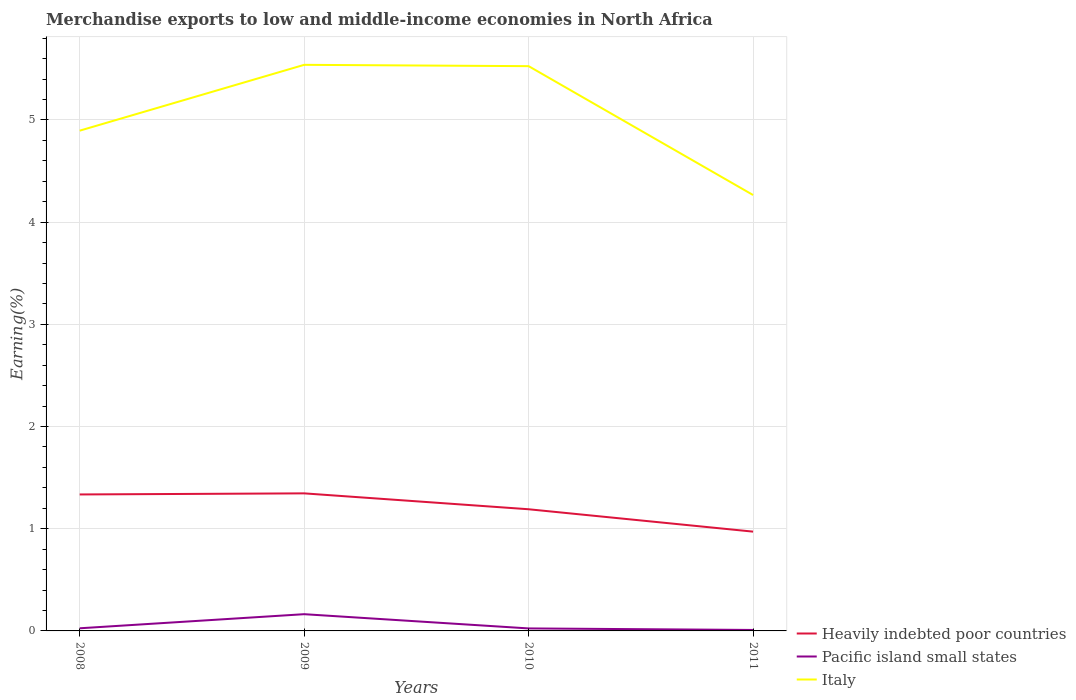How many different coloured lines are there?
Provide a short and direct response. 3. Is the number of lines equal to the number of legend labels?
Give a very brief answer. Yes. Across all years, what is the maximum percentage of amount earned from merchandise exports in Italy?
Offer a very short reply. 4.27. In which year was the percentage of amount earned from merchandise exports in Heavily indebted poor countries maximum?
Ensure brevity in your answer.  2011. What is the total percentage of amount earned from merchandise exports in Italy in the graph?
Ensure brevity in your answer.  1.26. What is the difference between the highest and the second highest percentage of amount earned from merchandise exports in Italy?
Your response must be concise. 1.27. How many years are there in the graph?
Keep it short and to the point. 4. What is the difference between two consecutive major ticks on the Y-axis?
Your answer should be very brief. 1. Does the graph contain any zero values?
Your response must be concise. No. Does the graph contain grids?
Your answer should be very brief. Yes. Where does the legend appear in the graph?
Offer a terse response. Bottom right. What is the title of the graph?
Ensure brevity in your answer.  Merchandise exports to low and middle-income economies in North Africa. Does "Saudi Arabia" appear as one of the legend labels in the graph?
Your answer should be compact. No. What is the label or title of the Y-axis?
Provide a short and direct response. Earning(%). What is the Earning(%) in Heavily indebted poor countries in 2008?
Give a very brief answer. 1.34. What is the Earning(%) of Pacific island small states in 2008?
Your answer should be very brief. 0.03. What is the Earning(%) of Italy in 2008?
Your answer should be compact. 4.89. What is the Earning(%) in Heavily indebted poor countries in 2009?
Give a very brief answer. 1.35. What is the Earning(%) of Pacific island small states in 2009?
Offer a very short reply. 0.16. What is the Earning(%) in Italy in 2009?
Ensure brevity in your answer.  5.54. What is the Earning(%) in Heavily indebted poor countries in 2010?
Offer a terse response. 1.19. What is the Earning(%) in Pacific island small states in 2010?
Your response must be concise. 0.02. What is the Earning(%) of Italy in 2010?
Make the answer very short. 5.53. What is the Earning(%) of Heavily indebted poor countries in 2011?
Offer a very short reply. 0.97. What is the Earning(%) in Pacific island small states in 2011?
Provide a succinct answer. 0.01. What is the Earning(%) in Italy in 2011?
Your answer should be very brief. 4.27. Across all years, what is the maximum Earning(%) of Heavily indebted poor countries?
Offer a very short reply. 1.35. Across all years, what is the maximum Earning(%) in Pacific island small states?
Make the answer very short. 0.16. Across all years, what is the maximum Earning(%) in Italy?
Give a very brief answer. 5.54. Across all years, what is the minimum Earning(%) of Heavily indebted poor countries?
Provide a succinct answer. 0.97. Across all years, what is the minimum Earning(%) of Pacific island small states?
Make the answer very short. 0.01. Across all years, what is the minimum Earning(%) of Italy?
Ensure brevity in your answer.  4.27. What is the total Earning(%) in Heavily indebted poor countries in the graph?
Your response must be concise. 4.84. What is the total Earning(%) in Pacific island small states in the graph?
Your response must be concise. 0.22. What is the total Earning(%) in Italy in the graph?
Your answer should be very brief. 20.23. What is the difference between the Earning(%) in Heavily indebted poor countries in 2008 and that in 2009?
Your response must be concise. -0.01. What is the difference between the Earning(%) in Pacific island small states in 2008 and that in 2009?
Provide a short and direct response. -0.14. What is the difference between the Earning(%) of Italy in 2008 and that in 2009?
Make the answer very short. -0.64. What is the difference between the Earning(%) in Heavily indebted poor countries in 2008 and that in 2010?
Make the answer very short. 0.14. What is the difference between the Earning(%) of Pacific island small states in 2008 and that in 2010?
Ensure brevity in your answer.  0. What is the difference between the Earning(%) of Italy in 2008 and that in 2010?
Your answer should be compact. -0.63. What is the difference between the Earning(%) of Heavily indebted poor countries in 2008 and that in 2011?
Keep it short and to the point. 0.36. What is the difference between the Earning(%) in Pacific island small states in 2008 and that in 2011?
Your answer should be compact. 0.02. What is the difference between the Earning(%) in Italy in 2008 and that in 2011?
Your answer should be very brief. 0.63. What is the difference between the Earning(%) of Heavily indebted poor countries in 2009 and that in 2010?
Your answer should be compact. 0.16. What is the difference between the Earning(%) of Pacific island small states in 2009 and that in 2010?
Your response must be concise. 0.14. What is the difference between the Earning(%) of Italy in 2009 and that in 2010?
Provide a succinct answer. 0.01. What is the difference between the Earning(%) in Heavily indebted poor countries in 2009 and that in 2011?
Give a very brief answer. 0.37. What is the difference between the Earning(%) of Pacific island small states in 2009 and that in 2011?
Give a very brief answer. 0.15. What is the difference between the Earning(%) in Italy in 2009 and that in 2011?
Provide a short and direct response. 1.27. What is the difference between the Earning(%) of Heavily indebted poor countries in 2010 and that in 2011?
Keep it short and to the point. 0.22. What is the difference between the Earning(%) in Pacific island small states in 2010 and that in 2011?
Give a very brief answer. 0.02. What is the difference between the Earning(%) of Italy in 2010 and that in 2011?
Ensure brevity in your answer.  1.26. What is the difference between the Earning(%) in Heavily indebted poor countries in 2008 and the Earning(%) in Pacific island small states in 2009?
Offer a very short reply. 1.17. What is the difference between the Earning(%) in Heavily indebted poor countries in 2008 and the Earning(%) in Italy in 2009?
Ensure brevity in your answer.  -4.2. What is the difference between the Earning(%) of Pacific island small states in 2008 and the Earning(%) of Italy in 2009?
Your answer should be compact. -5.51. What is the difference between the Earning(%) of Heavily indebted poor countries in 2008 and the Earning(%) of Pacific island small states in 2010?
Provide a short and direct response. 1.31. What is the difference between the Earning(%) of Heavily indebted poor countries in 2008 and the Earning(%) of Italy in 2010?
Give a very brief answer. -4.19. What is the difference between the Earning(%) of Pacific island small states in 2008 and the Earning(%) of Italy in 2010?
Make the answer very short. -5.5. What is the difference between the Earning(%) of Heavily indebted poor countries in 2008 and the Earning(%) of Pacific island small states in 2011?
Offer a terse response. 1.33. What is the difference between the Earning(%) in Heavily indebted poor countries in 2008 and the Earning(%) in Italy in 2011?
Offer a terse response. -2.93. What is the difference between the Earning(%) in Pacific island small states in 2008 and the Earning(%) in Italy in 2011?
Offer a very short reply. -4.24. What is the difference between the Earning(%) of Heavily indebted poor countries in 2009 and the Earning(%) of Pacific island small states in 2010?
Provide a succinct answer. 1.32. What is the difference between the Earning(%) of Heavily indebted poor countries in 2009 and the Earning(%) of Italy in 2010?
Your answer should be very brief. -4.18. What is the difference between the Earning(%) in Pacific island small states in 2009 and the Earning(%) in Italy in 2010?
Offer a very short reply. -5.36. What is the difference between the Earning(%) of Heavily indebted poor countries in 2009 and the Earning(%) of Pacific island small states in 2011?
Your response must be concise. 1.34. What is the difference between the Earning(%) in Heavily indebted poor countries in 2009 and the Earning(%) in Italy in 2011?
Your answer should be very brief. -2.92. What is the difference between the Earning(%) of Pacific island small states in 2009 and the Earning(%) of Italy in 2011?
Keep it short and to the point. -4.1. What is the difference between the Earning(%) of Heavily indebted poor countries in 2010 and the Earning(%) of Pacific island small states in 2011?
Your response must be concise. 1.18. What is the difference between the Earning(%) in Heavily indebted poor countries in 2010 and the Earning(%) in Italy in 2011?
Your answer should be very brief. -3.07. What is the difference between the Earning(%) of Pacific island small states in 2010 and the Earning(%) of Italy in 2011?
Ensure brevity in your answer.  -4.24. What is the average Earning(%) of Heavily indebted poor countries per year?
Your answer should be compact. 1.21. What is the average Earning(%) in Pacific island small states per year?
Your answer should be very brief. 0.06. What is the average Earning(%) in Italy per year?
Your answer should be very brief. 5.06. In the year 2008, what is the difference between the Earning(%) in Heavily indebted poor countries and Earning(%) in Pacific island small states?
Offer a very short reply. 1.31. In the year 2008, what is the difference between the Earning(%) of Heavily indebted poor countries and Earning(%) of Italy?
Provide a succinct answer. -3.56. In the year 2008, what is the difference between the Earning(%) in Pacific island small states and Earning(%) in Italy?
Your response must be concise. -4.87. In the year 2009, what is the difference between the Earning(%) in Heavily indebted poor countries and Earning(%) in Pacific island small states?
Ensure brevity in your answer.  1.18. In the year 2009, what is the difference between the Earning(%) of Heavily indebted poor countries and Earning(%) of Italy?
Offer a terse response. -4.19. In the year 2009, what is the difference between the Earning(%) of Pacific island small states and Earning(%) of Italy?
Provide a short and direct response. -5.38. In the year 2010, what is the difference between the Earning(%) of Heavily indebted poor countries and Earning(%) of Pacific island small states?
Give a very brief answer. 1.17. In the year 2010, what is the difference between the Earning(%) of Heavily indebted poor countries and Earning(%) of Italy?
Offer a very short reply. -4.34. In the year 2010, what is the difference between the Earning(%) of Pacific island small states and Earning(%) of Italy?
Provide a short and direct response. -5.5. In the year 2011, what is the difference between the Earning(%) in Heavily indebted poor countries and Earning(%) in Pacific island small states?
Keep it short and to the point. 0.96. In the year 2011, what is the difference between the Earning(%) in Heavily indebted poor countries and Earning(%) in Italy?
Make the answer very short. -3.29. In the year 2011, what is the difference between the Earning(%) in Pacific island small states and Earning(%) in Italy?
Offer a very short reply. -4.26. What is the ratio of the Earning(%) in Heavily indebted poor countries in 2008 to that in 2009?
Your answer should be very brief. 0.99. What is the ratio of the Earning(%) of Pacific island small states in 2008 to that in 2009?
Your answer should be compact. 0.16. What is the ratio of the Earning(%) in Italy in 2008 to that in 2009?
Keep it short and to the point. 0.88. What is the ratio of the Earning(%) of Heavily indebted poor countries in 2008 to that in 2010?
Offer a terse response. 1.12. What is the ratio of the Earning(%) of Pacific island small states in 2008 to that in 2010?
Keep it short and to the point. 1.05. What is the ratio of the Earning(%) of Italy in 2008 to that in 2010?
Your answer should be very brief. 0.89. What is the ratio of the Earning(%) in Heavily indebted poor countries in 2008 to that in 2011?
Your response must be concise. 1.37. What is the ratio of the Earning(%) in Pacific island small states in 2008 to that in 2011?
Make the answer very short. 2.74. What is the ratio of the Earning(%) in Italy in 2008 to that in 2011?
Your answer should be very brief. 1.15. What is the ratio of the Earning(%) in Heavily indebted poor countries in 2009 to that in 2010?
Your answer should be compact. 1.13. What is the ratio of the Earning(%) in Pacific island small states in 2009 to that in 2010?
Ensure brevity in your answer.  6.68. What is the ratio of the Earning(%) of Heavily indebted poor countries in 2009 to that in 2011?
Provide a succinct answer. 1.39. What is the ratio of the Earning(%) in Pacific island small states in 2009 to that in 2011?
Keep it short and to the point. 17.37. What is the ratio of the Earning(%) of Italy in 2009 to that in 2011?
Your answer should be very brief. 1.3. What is the ratio of the Earning(%) in Heavily indebted poor countries in 2010 to that in 2011?
Offer a very short reply. 1.23. What is the ratio of the Earning(%) in Pacific island small states in 2010 to that in 2011?
Your answer should be compact. 2.6. What is the ratio of the Earning(%) of Italy in 2010 to that in 2011?
Offer a terse response. 1.3. What is the difference between the highest and the second highest Earning(%) in Heavily indebted poor countries?
Your response must be concise. 0.01. What is the difference between the highest and the second highest Earning(%) in Pacific island small states?
Keep it short and to the point. 0.14. What is the difference between the highest and the second highest Earning(%) of Italy?
Offer a very short reply. 0.01. What is the difference between the highest and the lowest Earning(%) of Heavily indebted poor countries?
Provide a short and direct response. 0.37. What is the difference between the highest and the lowest Earning(%) in Pacific island small states?
Make the answer very short. 0.15. What is the difference between the highest and the lowest Earning(%) of Italy?
Keep it short and to the point. 1.27. 